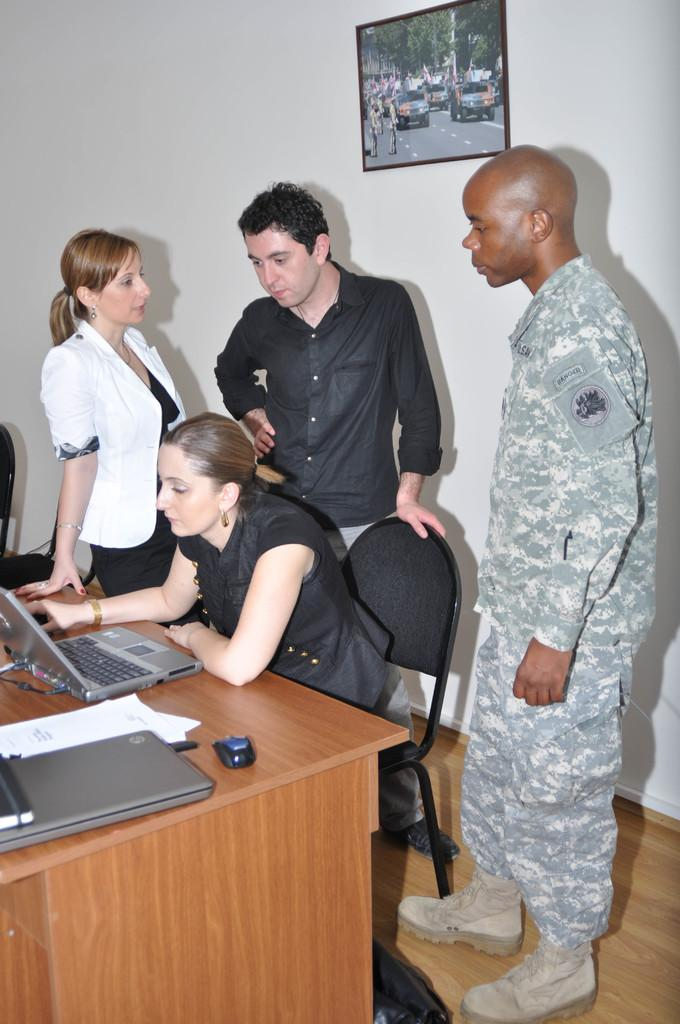What is the woman in the image doing? The woman is sitting on a chair in the image. What is in front of the woman? There is a table in front of the woman. What electronic device is on the table? A laptop is present on the table. What is used for input with the laptop? A mouse is on the table. What else is on the table besides the laptop and mouse? There are papers on the table. How many people are standing behind the woman? There are 3 people standing behind the woman. What is behind the woman? There is a wall behind the woman. What is hanging on the wall? There is a frame on the wall. What type of story can be seen being written on the calculator in the image? There is no calculator present in the image, and therefore no story can be seen being written on it. 